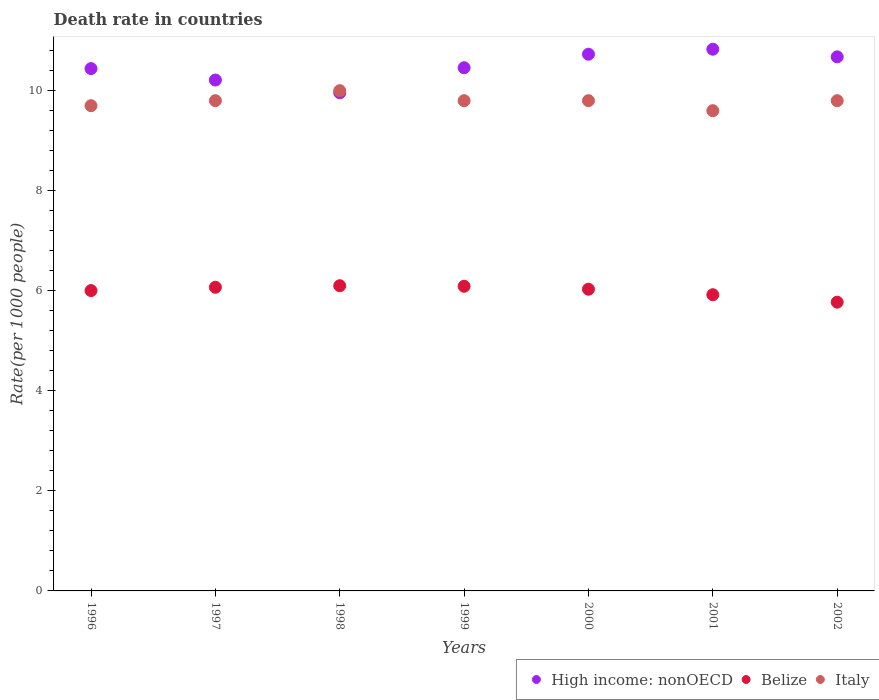What is the death rate in High income: nonOECD in 2002?
Offer a very short reply. 10.68. Across all years, what is the maximum death rate in High income: nonOECD?
Offer a terse response. 10.83. Across all years, what is the minimum death rate in High income: nonOECD?
Offer a terse response. 9.96. In which year was the death rate in Italy minimum?
Offer a terse response. 2001. What is the total death rate in Belize in the graph?
Your answer should be very brief. 41.99. What is the difference between the death rate in High income: nonOECD in 2002 and the death rate in Belize in 2000?
Your answer should be compact. 4.65. What is the average death rate in High income: nonOECD per year?
Provide a short and direct response. 10.47. In the year 1999, what is the difference between the death rate in Italy and death rate in High income: nonOECD?
Your answer should be very brief. -0.66. In how many years, is the death rate in Italy greater than 9.6?
Your response must be concise. 6. What is the ratio of the death rate in Italy in 1997 to that in 2000?
Your response must be concise. 1. Is the death rate in Belize in 1999 less than that in 2002?
Keep it short and to the point. No. Is the difference between the death rate in Italy in 1998 and 2002 greater than the difference between the death rate in High income: nonOECD in 1998 and 2002?
Give a very brief answer. Yes. What is the difference between the highest and the second highest death rate in Italy?
Give a very brief answer. 0.2. What is the difference between the highest and the lowest death rate in Belize?
Provide a succinct answer. 0.33. In how many years, is the death rate in Belize greater than the average death rate in Belize taken over all years?
Provide a short and direct response. 5. Is the sum of the death rate in Belize in 1997 and 2002 greater than the maximum death rate in High income: nonOECD across all years?
Provide a succinct answer. Yes. Is it the case that in every year, the sum of the death rate in High income: nonOECD and death rate in Belize  is greater than the death rate in Italy?
Ensure brevity in your answer.  Yes. Is the death rate in Belize strictly less than the death rate in High income: nonOECD over the years?
Your answer should be compact. Yes. How many years are there in the graph?
Give a very brief answer. 7. What is the difference between two consecutive major ticks on the Y-axis?
Your response must be concise. 2. Does the graph contain any zero values?
Your response must be concise. No. What is the title of the graph?
Your response must be concise. Death rate in countries. Does "Bosnia and Herzegovina" appear as one of the legend labels in the graph?
Your answer should be very brief. No. What is the label or title of the X-axis?
Make the answer very short. Years. What is the label or title of the Y-axis?
Your response must be concise. Rate(per 1000 people). What is the Rate(per 1000 people) in High income: nonOECD in 1996?
Provide a succinct answer. 10.44. What is the Rate(per 1000 people) of Belize in 1996?
Your answer should be compact. 6. What is the Rate(per 1000 people) in High income: nonOECD in 1997?
Offer a very short reply. 10.21. What is the Rate(per 1000 people) of Belize in 1997?
Your answer should be very brief. 6.07. What is the Rate(per 1000 people) of Italy in 1997?
Ensure brevity in your answer.  9.8. What is the Rate(per 1000 people) in High income: nonOECD in 1998?
Offer a terse response. 9.96. What is the Rate(per 1000 people) in Belize in 1998?
Make the answer very short. 6.1. What is the Rate(per 1000 people) in High income: nonOECD in 1999?
Offer a very short reply. 10.46. What is the Rate(per 1000 people) in Belize in 1999?
Offer a terse response. 6.09. What is the Rate(per 1000 people) in Italy in 1999?
Provide a short and direct response. 9.8. What is the Rate(per 1000 people) in High income: nonOECD in 2000?
Your answer should be very brief. 10.73. What is the Rate(per 1000 people) of Belize in 2000?
Provide a succinct answer. 6.03. What is the Rate(per 1000 people) of High income: nonOECD in 2001?
Keep it short and to the point. 10.83. What is the Rate(per 1000 people) in Belize in 2001?
Make the answer very short. 5.92. What is the Rate(per 1000 people) in Italy in 2001?
Your answer should be very brief. 9.6. What is the Rate(per 1000 people) in High income: nonOECD in 2002?
Your answer should be very brief. 10.68. What is the Rate(per 1000 people) of Belize in 2002?
Provide a short and direct response. 5.77. What is the Rate(per 1000 people) of Italy in 2002?
Your answer should be compact. 9.8. Across all years, what is the maximum Rate(per 1000 people) of High income: nonOECD?
Provide a short and direct response. 10.83. Across all years, what is the maximum Rate(per 1000 people) of Belize?
Your answer should be very brief. 6.1. Across all years, what is the minimum Rate(per 1000 people) in High income: nonOECD?
Offer a terse response. 9.96. Across all years, what is the minimum Rate(per 1000 people) in Belize?
Ensure brevity in your answer.  5.77. Across all years, what is the minimum Rate(per 1000 people) of Italy?
Your answer should be very brief. 9.6. What is the total Rate(per 1000 people) in High income: nonOECD in the graph?
Your answer should be compact. 73.3. What is the total Rate(per 1000 people) of Belize in the graph?
Provide a short and direct response. 41.99. What is the total Rate(per 1000 people) in Italy in the graph?
Give a very brief answer. 68.5. What is the difference between the Rate(per 1000 people) of High income: nonOECD in 1996 and that in 1997?
Offer a very short reply. 0.23. What is the difference between the Rate(per 1000 people) in Belize in 1996 and that in 1997?
Provide a succinct answer. -0.07. What is the difference between the Rate(per 1000 people) of Italy in 1996 and that in 1997?
Offer a very short reply. -0.1. What is the difference between the Rate(per 1000 people) of High income: nonOECD in 1996 and that in 1998?
Offer a terse response. 0.48. What is the difference between the Rate(per 1000 people) in Belize in 1996 and that in 1998?
Keep it short and to the point. -0.1. What is the difference between the Rate(per 1000 people) in High income: nonOECD in 1996 and that in 1999?
Your answer should be compact. -0.02. What is the difference between the Rate(per 1000 people) of Belize in 1996 and that in 1999?
Offer a very short reply. -0.09. What is the difference between the Rate(per 1000 people) in Italy in 1996 and that in 1999?
Make the answer very short. -0.1. What is the difference between the Rate(per 1000 people) of High income: nonOECD in 1996 and that in 2000?
Your answer should be compact. -0.29. What is the difference between the Rate(per 1000 people) of Belize in 1996 and that in 2000?
Offer a terse response. -0.03. What is the difference between the Rate(per 1000 people) of High income: nonOECD in 1996 and that in 2001?
Offer a terse response. -0.39. What is the difference between the Rate(per 1000 people) in Belize in 1996 and that in 2001?
Make the answer very short. 0.08. What is the difference between the Rate(per 1000 people) in High income: nonOECD in 1996 and that in 2002?
Make the answer very short. -0.23. What is the difference between the Rate(per 1000 people) of Belize in 1996 and that in 2002?
Provide a succinct answer. 0.23. What is the difference between the Rate(per 1000 people) in Italy in 1996 and that in 2002?
Offer a terse response. -0.1. What is the difference between the Rate(per 1000 people) in High income: nonOECD in 1997 and that in 1998?
Your answer should be compact. 0.25. What is the difference between the Rate(per 1000 people) in Belize in 1997 and that in 1998?
Offer a terse response. -0.03. What is the difference between the Rate(per 1000 people) of Italy in 1997 and that in 1998?
Keep it short and to the point. -0.2. What is the difference between the Rate(per 1000 people) of High income: nonOECD in 1997 and that in 1999?
Keep it short and to the point. -0.25. What is the difference between the Rate(per 1000 people) of Belize in 1997 and that in 1999?
Ensure brevity in your answer.  -0.02. What is the difference between the Rate(per 1000 people) in High income: nonOECD in 1997 and that in 2000?
Give a very brief answer. -0.52. What is the difference between the Rate(per 1000 people) in Belize in 1997 and that in 2000?
Your answer should be very brief. 0.04. What is the difference between the Rate(per 1000 people) of High income: nonOECD in 1997 and that in 2001?
Keep it short and to the point. -0.62. What is the difference between the Rate(per 1000 people) of Belize in 1997 and that in 2001?
Your answer should be compact. 0.15. What is the difference between the Rate(per 1000 people) of High income: nonOECD in 1997 and that in 2002?
Offer a very short reply. -0.46. What is the difference between the Rate(per 1000 people) of Belize in 1997 and that in 2002?
Ensure brevity in your answer.  0.3. What is the difference between the Rate(per 1000 people) in Italy in 1997 and that in 2002?
Provide a short and direct response. 0. What is the difference between the Rate(per 1000 people) of High income: nonOECD in 1998 and that in 1999?
Provide a short and direct response. -0.5. What is the difference between the Rate(per 1000 people) of Belize in 1998 and that in 1999?
Provide a succinct answer. 0.01. What is the difference between the Rate(per 1000 people) of High income: nonOECD in 1998 and that in 2000?
Your answer should be very brief. -0.77. What is the difference between the Rate(per 1000 people) of Belize in 1998 and that in 2000?
Provide a succinct answer. 0.07. What is the difference between the Rate(per 1000 people) of Italy in 1998 and that in 2000?
Give a very brief answer. 0.2. What is the difference between the Rate(per 1000 people) of High income: nonOECD in 1998 and that in 2001?
Offer a terse response. -0.87. What is the difference between the Rate(per 1000 people) of Belize in 1998 and that in 2001?
Your response must be concise. 0.18. What is the difference between the Rate(per 1000 people) in High income: nonOECD in 1998 and that in 2002?
Your answer should be compact. -0.72. What is the difference between the Rate(per 1000 people) in Belize in 1998 and that in 2002?
Make the answer very short. 0.33. What is the difference between the Rate(per 1000 people) in High income: nonOECD in 1999 and that in 2000?
Provide a short and direct response. -0.27. What is the difference between the Rate(per 1000 people) of Belize in 1999 and that in 2000?
Offer a terse response. 0.06. What is the difference between the Rate(per 1000 people) of Italy in 1999 and that in 2000?
Provide a succinct answer. 0. What is the difference between the Rate(per 1000 people) of High income: nonOECD in 1999 and that in 2001?
Your answer should be very brief. -0.37. What is the difference between the Rate(per 1000 people) of Belize in 1999 and that in 2001?
Provide a short and direct response. 0.17. What is the difference between the Rate(per 1000 people) in High income: nonOECD in 1999 and that in 2002?
Offer a terse response. -0.22. What is the difference between the Rate(per 1000 people) in Belize in 1999 and that in 2002?
Give a very brief answer. 0.32. What is the difference between the Rate(per 1000 people) of High income: nonOECD in 2000 and that in 2001?
Ensure brevity in your answer.  -0.1. What is the difference between the Rate(per 1000 people) in Belize in 2000 and that in 2001?
Keep it short and to the point. 0.11. What is the difference between the Rate(per 1000 people) of High income: nonOECD in 2000 and that in 2002?
Give a very brief answer. 0.05. What is the difference between the Rate(per 1000 people) of Belize in 2000 and that in 2002?
Offer a terse response. 0.26. What is the difference between the Rate(per 1000 people) of Italy in 2000 and that in 2002?
Offer a terse response. 0. What is the difference between the Rate(per 1000 people) of High income: nonOECD in 2001 and that in 2002?
Ensure brevity in your answer.  0.15. What is the difference between the Rate(per 1000 people) of Belize in 2001 and that in 2002?
Offer a terse response. 0.15. What is the difference between the Rate(per 1000 people) in Italy in 2001 and that in 2002?
Keep it short and to the point. -0.2. What is the difference between the Rate(per 1000 people) in High income: nonOECD in 1996 and the Rate(per 1000 people) in Belize in 1997?
Make the answer very short. 4.37. What is the difference between the Rate(per 1000 people) of High income: nonOECD in 1996 and the Rate(per 1000 people) of Italy in 1997?
Your answer should be very brief. 0.64. What is the difference between the Rate(per 1000 people) of Belize in 1996 and the Rate(per 1000 people) of Italy in 1997?
Ensure brevity in your answer.  -3.8. What is the difference between the Rate(per 1000 people) in High income: nonOECD in 1996 and the Rate(per 1000 people) in Belize in 1998?
Offer a terse response. 4.34. What is the difference between the Rate(per 1000 people) in High income: nonOECD in 1996 and the Rate(per 1000 people) in Italy in 1998?
Give a very brief answer. 0.44. What is the difference between the Rate(per 1000 people) in Belize in 1996 and the Rate(per 1000 people) in Italy in 1998?
Provide a short and direct response. -4. What is the difference between the Rate(per 1000 people) in High income: nonOECD in 1996 and the Rate(per 1000 people) in Belize in 1999?
Give a very brief answer. 4.35. What is the difference between the Rate(per 1000 people) of High income: nonOECD in 1996 and the Rate(per 1000 people) of Italy in 1999?
Your response must be concise. 0.64. What is the difference between the Rate(per 1000 people) of Belize in 1996 and the Rate(per 1000 people) of Italy in 1999?
Make the answer very short. -3.8. What is the difference between the Rate(per 1000 people) of High income: nonOECD in 1996 and the Rate(per 1000 people) of Belize in 2000?
Ensure brevity in your answer.  4.41. What is the difference between the Rate(per 1000 people) in High income: nonOECD in 1996 and the Rate(per 1000 people) in Italy in 2000?
Make the answer very short. 0.64. What is the difference between the Rate(per 1000 people) of Belize in 1996 and the Rate(per 1000 people) of Italy in 2000?
Your response must be concise. -3.8. What is the difference between the Rate(per 1000 people) of High income: nonOECD in 1996 and the Rate(per 1000 people) of Belize in 2001?
Offer a very short reply. 4.52. What is the difference between the Rate(per 1000 people) in High income: nonOECD in 1996 and the Rate(per 1000 people) in Italy in 2001?
Offer a terse response. 0.84. What is the difference between the Rate(per 1000 people) in Belize in 1996 and the Rate(per 1000 people) in Italy in 2001?
Offer a terse response. -3.6. What is the difference between the Rate(per 1000 people) of High income: nonOECD in 1996 and the Rate(per 1000 people) of Belize in 2002?
Offer a very short reply. 4.67. What is the difference between the Rate(per 1000 people) of High income: nonOECD in 1996 and the Rate(per 1000 people) of Italy in 2002?
Your answer should be very brief. 0.64. What is the difference between the Rate(per 1000 people) in Belize in 1996 and the Rate(per 1000 people) in Italy in 2002?
Offer a very short reply. -3.8. What is the difference between the Rate(per 1000 people) in High income: nonOECD in 1997 and the Rate(per 1000 people) in Belize in 1998?
Keep it short and to the point. 4.11. What is the difference between the Rate(per 1000 people) of High income: nonOECD in 1997 and the Rate(per 1000 people) of Italy in 1998?
Make the answer very short. 0.21. What is the difference between the Rate(per 1000 people) in Belize in 1997 and the Rate(per 1000 people) in Italy in 1998?
Make the answer very short. -3.93. What is the difference between the Rate(per 1000 people) in High income: nonOECD in 1997 and the Rate(per 1000 people) in Belize in 1999?
Ensure brevity in your answer.  4.12. What is the difference between the Rate(per 1000 people) of High income: nonOECD in 1997 and the Rate(per 1000 people) of Italy in 1999?
Offer a very short reply. 0.41. What is the difference between the Rate(per 1000 people) in Belize in 1997 and the Rate(per 1000 people) in Italy in 1999?
Keep it short and to the point. -3.73. What is the difference between the Rate(per 1000 people) in High income: nonOECD in 1997 and the Rate(per 1000 people) in Belize in 2000?
Ensure brevity in your answer.  4.18. What is the difference between the Rate(per 1000 people) of High income: nonOECD in 1997 and the Rate(per 1000 people) of Italy in 2000?
Offer a terse response. 0.41. What is the difference between the Rate(per 1000 people) in Belize in 1997 and the Rate(per 1000 people) in Italy in 2000?
Your answer should be very brief. -3.73. What is the difference between the Rate(per 1000 people) of High income: nonOECD in 1997 and the Rate(per 1000 people) of Belize in 2001?
Provide a short and direct response. 4.29. What is the difference between the Rate(per 1000 people) of High income: nonOECD in 1997 and the Rate(per 1000 people) of Italy in 2001?
Your answer should be very brief. 0.61. What is the difference between the Rate(per 1000 people) in Belize in 1997 and the Rate(per 1000 people) in Italy in 2001?
Ensure brevity in your answer.  -3.53. What is the difference between the Rate(per 1000 people) of High income: nonOECD in 1997 and the Rate(per 1000 people) of Belize in 2002?
Provide a succinct answer. 4.44. What is the difference between the Rate(per 1000 people) in High income: nonOECD in 1997 and the Rate(per 1000 people) in Italy in 2002?
Provide a short and direct response. 0.41. What is the difference between the Rate(per 1000 people) of Belize in 1997 and the Rate(per 1000 people) of Italy in 2002?
Your answer should be compact. -3.73. What is the difference between the Rate(per 1000 people) in High income: nonOECD in 1998 and the Rate(per 1000 people) in Belize in 1999?
Your answer should be compact. 3.87. What is the difference between the Rate(per 1000 people) of High income: nonOECD in 1998 and the Rate(per 1000 people) of Italy in 1999?
Provide a short and direct response. 0.16. What is the difference between the Rate(per 1000 people) in Belize in 1998 and the Rate(per 1000 people) in Italy in 1999?
Make the answer very short. -3.7. What is the difference between the Rate(per 1000 people) in High income: nonOECD in 1998 and the Rate(per 1000 people) in Belize in 2000?
Offer a terse response. 3.93. What is the difference between the Rate(per 1000 people) of High income: nonOECD in 1998 and the Rate(per 1000 people) of Italy in 2000?
Ensure brevity in your answer.  0.16. What is the difference between the Rate(per 1000 people) of Belize in 1998 and the Rate(per 1000 people) of Italy in 2000?
Offer a very short reply. -3.7. What is the difference between the Rate(per 1000 people) of High income: nonOECD in 1998 and the Rate(per 1000 people) of Belize in 2001?
Provide a short and direct response. 4.04. What is the difference between the Rate(per 1000 people) in High income: nonOECD in 1998 and the Rate(per 1000 people) in Italy in 2001?
Your answer should be compact. 0.36. What is the difference between the Rate(per 1000 people) in Belize in 1998 and the Rate(per 1000 people) in Italy in 2001?
Your answer should be very brief. -3.5. What is the difference between the Rate(per 1000 people) of High income: nonOECD in 1998 and the Rate(per 1000 people) of Belize in 2002?
Keep it short and to the point. 4.19. What is the difference between the Rate(per 1000 people) of High income: nonOECD in 1998 and the Rate(per 1000 people) of Italy in 2002?
Ensure brevity in your answer.  0.16. What is the difference between the Rate(per 1000 people) in Belize in 1998 and the Rate(per 1000 people) in Italy in 2002?
Provide a short and direct response. -3.7. What is the difference between the Rate(per 1000 people) in High income: nonOECD in 1999 and the Rate(per 1000 people) in Belize in 2000?
Keep it short and to the point. 4.43. What is the difference between the Rate(per 1000 people) in High income: nonOECD in 1999 and the Rate(per 1000 people) in Italy in 2000?
Provide a short and direct response. 0.66. What is the difference between the Rate(per 1000 people) in Belize in 1999 and the Rate(per 1000 people) in Italy in 2000?
Offer a very short reply. -3.71. What is the difference between the Rate(per 1000 people) in High income: nonOECD in 1999 and the Rate(per 1000 people) in Belize in 2001?
Your answer should be compact. 4.54. What is the difference between the Rate(per 1000 people) in High income: nonOECD in 1999 and the Rate(per 1000 people) in Italy in 2001?
Provide a succinct answer. 0.86. What is the difference between the Rate(per 1000 people) in Belize in 1999 and the Rate(per 1000 people) in Italy in 2001?
Offer a very short reply. -3.51. What is the difference between the Rate(per 1000 people) in High income: nonOECD in 1999 and the Rate(per 1000 people) in Belize in 2002?
Give a very brief answer. 4.69. What is the difference between the Rate(per 1000 people) of High income: nonOECD in 1999 and the Rate(per 1000 people) of Italy in 2002?
Make the answer very short. 0.66. What is the difference between the Rate(per 1000 people) in Belize in 1999 and the Rate(per 1000 people) in Italy in 2002?
Ensure brevity in your answer.  -3.71. What is the difference between the Rate(per 1000 people) of High income: nonOECD in 2000 and the Rate(per 1000 people) of Belize in 2001?
Provide a short and direct response. 4.81. What is the difference between the Rate(per 1000 people) in High income: nonOECD in 2000 and the Rate(per 1000 people) in Italy in 2001?
Your answer should be compact. 1.13. What is the difference between the Rate(per 1000 people) of Belize in 2000 and the Rate(per 1000 people) of Italy in 2001?
Your answer should be compact. -3.57. What is the difference between the Rate(per 1000 people) of High income: nonOECD in 2000 and the Rate(per 1000 people) of Belize in 2002?
Make the answer very short. 4.96. What is the difference between the Rate(per 1000 people) of High income: nonOECD in 2000 and the Rate(per 1000 people) of Italy in 2002?
Give a very brief answer. 0.93. What is the difference between the Rate(per 1000 people) of Belize in 2000 and the Rate(per 1000 people) of Italy in 2002?
Give a very brief answer. -3.77. What is the difference between the Rate(per 1000 people) in High income: nonOECD in 2001 and the Rate(per 1000 people) in Belize in 2002?
Provide a succinct answer. 5.06. What is the difference between the Rate(per 1000 people) in High income: nonOECD in 2001 and the Rate(per 1000 people) in Italy in 2002?
Your answer should be compact. 1.03. What is the difference between the Rate(per 1000 people) in Belize in 2001 and the Rate(per 1000 people) in Italy in 2002?
Offer a terse response. -3.88. What is the average Rate(per 1000 people) of High income: nonOECD per year?
Keep it short and to the point. 10.47. What is the average Rate(per 1000 people) in Belize per year?
Provide a short and direct response. 6. What is the average Rate(per 1000 people) of Italy per year?
Your response must be concise. 9.79. In the year 1996, what is the difference between the Rate(per 1000 people) in High income: nonOECD and Rate(per 1000 people) in Belize?
Make the answer very short. 4.44. In the year 1996, what is the difference between the Rate(per 1000 people) in High income: nonOECD and Rate(per 1000 people) in Italy?
Provide a succinct answer. 0.74. In the year 1996, what is the difference between the Rate(per 1000 people) in Belize and Rate(per 1000 people) in Italy?
Your response must be concise. -3.7. In the year 1997, what is the difference between the Rate(per 1000 people) of High income: nonOECD and Rate(per 1000 people) of Belize?
Ensure brevity in your answer.  4.14. In the year 1997, what is the difference between the Rate(per 1000 people) of High income: nonOECD and Rate(per 1000 people) of Italy?
Your answer should be very brief. 0.41. In the year 1997, what is the difference between the Rate(per 1000 people) in Belize and Rate(per 1000 people) in Italy?
Make the answer very short. -3.73. In the year 1998, what is the difference between the Rate(per 1000 people) of High income: nonOECD and Rate(per 1000 people) of Belize?
Ensure brevity in your answer.  3.86. In the year 1998, what is the difference between the Rate(per 1000 people) in High income: nonOECD and Rate(per 1000 people) in Italy?
Keep it short and to the point. -0.04. In the year 1998, what is the difference between the Rate(per 1000 people) in Belize and Rate(per 1000 people) in Italy?
Your response must be concise. -3.9. In the year 1999, what is the difference between the Rate(per 1000 people) of High income: nonOECD and Rate(per 1000 people) of Belize?
Your answer should be compact. 4.37. In the year 1999, what is the difference between the Rate(per 1000 people) of High income: nonOECD and Rate(per 1000 people) of Italy?
Your answer should be compact. 0.66. In the year 1999, what is the difference between the Rate(per 1000 people) of Belize and Rate(per 1000 people) of Italy?
Make the answer very short. -3.71. In the year 2000, what is the difference between the Rate(per 1000 people) of High income: nonOECD and Rate(per 1000 people) of Belize?
Offer a very short reply. 4.7. In the year 2000, what is the difference between the Rate(per 1000 people) of High income: nonOECD and Rate(per 1000 people) of Italy?
Provide a succinct answer. 0.93. In the year 2000, what is the difference between the Rate(per 1000 people) in Belize and Rate(per 1000 people) in Italy?
Give a very brief answer. -3.77. In the year 2001, what is the difference between the Rate(per 1000 people) in High income: nonOECD and Rate(per 1000 people) in Belize?
Give a very brief answer. 4.91. In the year 2001, what is the difference between the Rate(per 1000 people) of High income: nonOECD and Rate(per 1000 people) of Italy?
Keep it short and to the point. 1.23. In the year 2001, what is the difference between the Rate(per 1000 people) of Belize and Rate(per 1000 people) of Italy?
Ensure brevity in your answer.  -3.68. In the year 2002, what is the difference between the Rate(per 1000 people) of High income: nonOECD and Rate(per 1000 people) of Belize?
Provide a short and direct response. 4.9. In the year 2002, what is the difference between the Rate(per 1000 people) in High income: nonOECD and Rate(per 1000 people) in Italy?
Your response must be concise. 0.88. In the year 2002, what is the difference between the Rate(per 1000 people) of Belize and Rate(per 1000 people) of Italy?
Your answer should be compact. -4.03. What is the ratio of the Rate(per 1000 people) in High income: nonOECD in 1996 to that in 1997?
Offer a very short reply. 1.02. What is the ratio of the Rate(per 1000 people) in Belize in 1996 to that in 1997?
Provide a short and direct response. 0.99. What is the ratio of the Rate(per 1000 people) in Italy in 1996 to that in 1997?
Provide a short and direct response. 0.99. What is the ratio of the Rate(per 1000 people) of High income: nonOECD in 1996 to that in 1998?
Make the answer very short. 1.05. What is the ratio of the Rate(per 1000 people) of Belize in 1996 to that in 1998?
Give a very brief answer. 0.98. What is the ratio of the Rate(per 1000 people) in Italy in 1996 to that in 1998?
Your answer should be very brief. 0.97. What is the ratio of the Rate(per 1000 people) of Belize in 1996 to that in 1999?
Your answer should be very brief. 0.99. What is the ratio of the Rate(per 1000 people) in Italy in 1996 to that in 1999?
Offer a very short reply. 0.99. What is the ratio of the Rate(per 1000 people) in High income: nonOECD in 1996 to that in 2000?
Keep it short and to the point. 0.97. What is the ratio of the Rate(per 1000 people) of Italy in 1996 to that in 2000?
Give a very brief answer. 0.99. What is the ratio of the Rate(per 1000 people) in High income: nonOECD in 1996 to that in 2001?
Your answer should be very brief. 0.96. What is the ratio of the Rate(per 1000 people) of Belize in 1996 to that in 2001?
Your answer should be very brief. 1.01. What is the ratio of the Rate(per 1000 people) of Italy in 1996 to that in 2001?
Provide a short and direct response. 1.01. What is the ratio of the Rate(per 1000 people) in High income: nonOECD in 1996 to that in 2002?
Offer a terse response. 0.98. What is the ratio of the Rate(per 1000 people) in Belize in 1996 to that in 2002?
Offer a very short reply. 1.04. What is the ratio of the Rate(per 1000 people) in High income: nonOECD in 1997 to that in 1998?
Give a very brief answer. 1.03. What is the ratio of the Rate(per 1000 people) of High income: nonOECD in 1997 to that in 1999?
Your answer should be compact. 0.98. What is the ratio of the Rate(per 1000 people) of Belize in 1997 to that in 1999?
Your response must be concise. 1. What is the ratio of the Rate(per 1000 people) of High income: nonOECD in 1997 to that in 2000?
Provide a succinct answer. 0.95. What is the ratio of the Rate(per 1000 people) of Belize in 1997 to that in 2000?
Provide a succinct answer. 1.01. What is the ratio of the Rate(per 1000 people) in Italy in 1997 to that in 2000?
Your response must be concise. 1. What is the ratio of the Rate(per 1000 people) in High income: nonOECD in 1997 to that in 2001?
Offer a terse response. 0.94. What is the ratio of the Rate(per 1000 people) of Belize in 1997 to that in 2001?
Offer a terse response. 1.03. What is the ratio of the Rate(per 1000 people) in Italy in 1997 to that in 2001?
Provide a succinct answer. 1.02. What is the ratio of the Rate(per 1000 people) of High income: nonOECD in 1997 to that in 2002?
Provide a succinct answer. 0.96. What is the ratio of the Rate(per 1000 people) in Belize in 1997 to that in 2002?
Provide a short and direct response. 1.05. What is the ratio of the Rate(per 1000 people) in Italy in 1997 to that in 2002?
Your response must be concise. 1. What is the ratio of the Rate(per 1000 people) of High income: nonOECD in 1998 to that in 1999?
Keep it short and to the point. 0.95. What is the ratio of the Rate(per 1000 people) in Belize in 1998 to that in 1999?
Your response must be concise. 1. What is the ratio of the Rate(per 1000 people) of Italy in 1998 to that in 1999?
Offer a very short reply. 1.02. What is the ratio of the Rate(per 1000 people) of High income: nonOECD in 1998 to that in 2000?
Your answer should be compact. 0.93. What is the ratio of the Rate(per 1000 people) of Belize in 1998 to that in 2000?
Give a very brief answer. 1.01. What is the ratio of the Rate(per 1000 people) of Italy in 1998 to that in 2000?
Your answer should be compact. 1.02. What is the ratio of the Rate(per 1000 people) in High income: nonOECD in 1998 to that in 2001?
Keep it short and to the point. 0.92. What is the ratio of the Rate(per 1000 people) in Belize in 1998 to that in 2001?
Your answer should be very brief. 1.03. What is the ratio of the Rate(per 1000 people) of Italy in 1998 to that in 2001?
Provide a succinct answer. 1.04. What is the ratio of the Rate(per 1000 people) of High income: nonOECD in 1998 to that in 2002?
Offer a terse response. 0.93. What is the ratio of the Rate(per 1000 people) in Belize in 1998 to that in 2002?
Keep it short and to the point. 1.06. What is the ratio of the Rate(per 1000 people) in Italy in 1998 to that in 2002?
Offer a terse response. 1.02. What is the ratio of the Rate(per 1000 people) of High income: nonOECD in 1999 to that in 2000?
Your answer should be compact. 0.97. What is the ratio of the Rate(per 1000 people) in Belize in 1999 to that in 2000?
Provide a short and direct response. 1.01. What is the ratio of the Rate(per 1000 people) of Italy in 1999 to that in 2000?
Give a very brief answer. 1. What is the ratio of the Rate(per 1000 people) of High income: nonOECD in 1999 to that in 2001?
Your answer should be very brief. 0.97. What is the ratio of the Rate(per 1000 people) in Belize in 1999 to that in 2001?
Offer a very short reply. 1.03. What is the ratio of the Rate(per 1000 people) of Italy in 1999 to that in 2001?
Provide a succinct answer. 1.02. What is the ratio of the Rate(per 1000 people) in High income: nonOECD in 1999 to that in 2002?
Make the answer very short. 0.98. What is the ratio of the Rate(per 1000 people) in Belize in 1999 to that in 2002?
Offer a terse response. 1.06. What is the ratio of the Rate(per 1000 people) in Belize in 2000 to that in 2001?
Your answer should be very brief. 1.02. What is the ratio of the Rate(per 1000 people) in Italy in 2000 to that in 2001?
Offer a terse response. 1.02. What is the ratio of the Rate(per 1000 people) of High income: nonOECD in 2000 to that in 2002?
Give a very brief answer. 1. What is the ratio of the Rate(per 1000 people) in Belize in 2000 to that in 2002?
Make the answer very short. 1.04. What is the ratio of the Rate(per 1000 people) of High income: nonOECD in 2001 to that in 2002?
Give a very brief answer. 1.01. What is the ratio of the Rate(per 1000 people) of Belize in 2001 to that in 2002?
Offer a very short reply. 1.03. What is the ratio of the Rate(per 1000 people) of Italy in 2001 to that in 2002?
Keep it short and to the point. 0.98. What is the difference between the highest and the second highest Rate(per 1000 people) of High income: nonOECD?
Keep it short and to the point. 0.1. What is the difference between the highest and the second highest Rate(per 1000 people) of Belize?
Your answer should be compact. 0.01. What is the difference between the highest and the lowest Rate(per 1000 people) in High income: nonOECD?
Make the answer very short. 0.87. What is the difference between the highest and the lowest Rate(per 1000 people) of Belize?
Offer a very short reply. 0.33. What is the difference between the highest and the lowest Rate(per 1000 people) of Italy?
Your answer should be very brief. 0.4. 